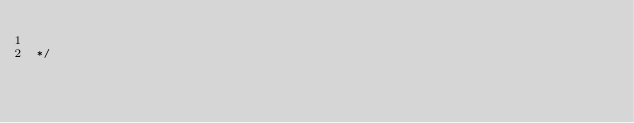<code> <loc_0><loc_0><loc_500><loc_500><_Rust_>
*/
</code> 